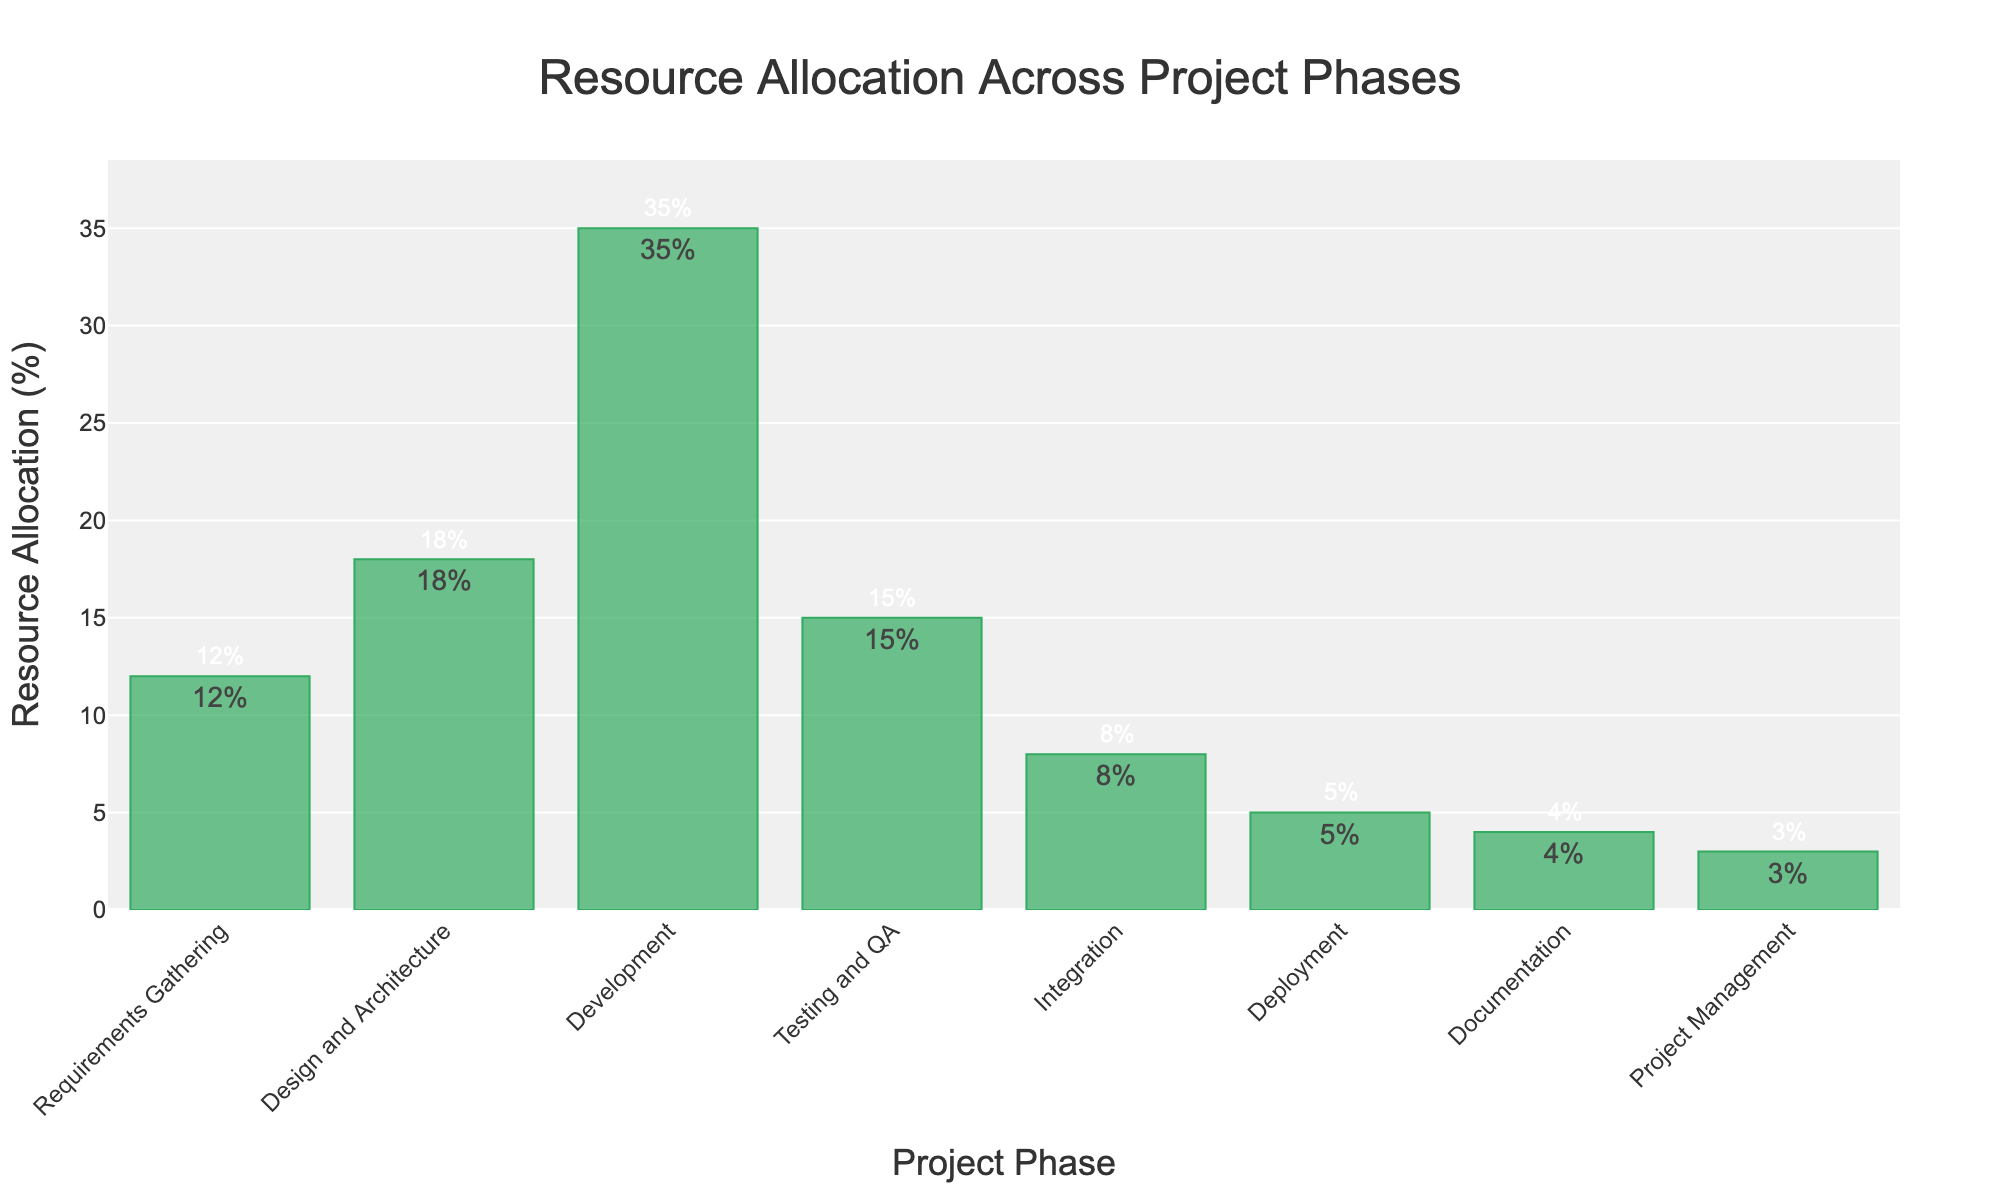What is the project phase with the highest resource allocation? By examining the heights of the bars, the "Development" phase has the tallest bar indicating it has the highest resource allocation percentage.
Answer: Development Which project phase has the lowest resource allocation? The "Project Management" phase has the shortest bar, signifying it has the lowest resource allocation percentage.
Answer: Project Management How much more resource allocation does Development have compared to Testing and QA? The "Development" phase has 35% allocation, while "Testing and QA" has 15%. The difference is 35% - 15% = 20%.
Answer: 20% What is the total percentage of resource allocation for Design and Architecture, and Documentation combined? Design and Architecture has 18%, and Documentation has 4%. Summing them gives 18% + 4% = 22%.
Answer: 22% How does the resource allocation for Integration compare to Deployment? The "Integration" phase has 8% resource allocation, and the "Deployment" phase has 5%. So, Integration has 8% - 5% = 3% more allocation than Deployment.
Answer: 3% What is the sum of resource allocations for all phases? Adding the resource allocations of all phases: 12% (Requirements Gathering) + 18% (Design and Architecture) + 35% (Development) + 15% (Testing and QA) + 8% (Integration) + 5% (Deployment) + 4% (Documentation) + 3% (Project Management) = 100%.
Answer: 100% Which phases have a resource allocation higher than the average resource allocation across all phases? The average resource allocation across all phases is 100% / 8 = 12.5%. The phases with allocations higher than 12.5% are "Design and Architecture" (18%), "Development" (35%), and "Testing and QA" (15%).
Answer: Design and Architecture, Development, Testing and QA What is the approximate difference in resource allocation between the highest (Development) and the lowest (Project Management) phases? The "Development" phase has 35% allocation, and the "Project Management" phase has 3%. The difference is 35% - 3% = 32%.
Answer: 32% What is the total resource allocation percentage for requirements-related phases (Requirements Gathering and Design and Architecture)? Requirements Gathering has 12%, and Design and Architecture has 18%. Their combined total is 12% + 18% = 30%.
Answer: 30% If Testing and QA's allocation increased by 50%, what would the new allocation be? The current allocation for Testing and QA is 15%. An increase of 50% means adding 50% of 15%, which is 0.5 * 15 = 7.5%. The new allocation would be 15% + 7.5% = 22.5%.
Answer: 22.5% 